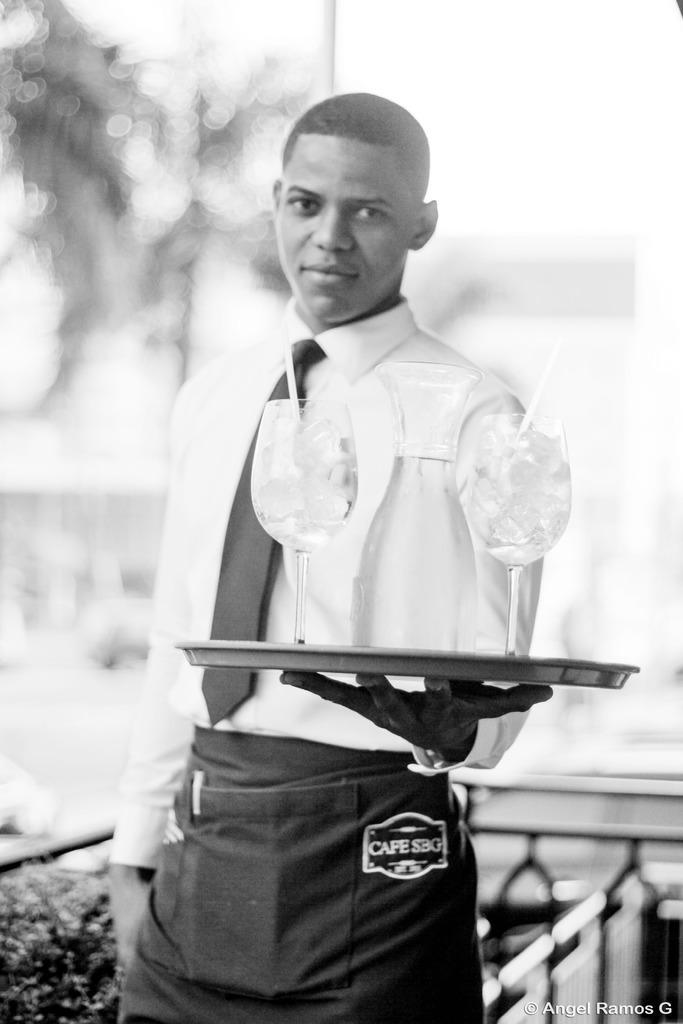Can you describe this image briefly? A black and white image. This man is holding a tray with glasses. Background it is blur. 